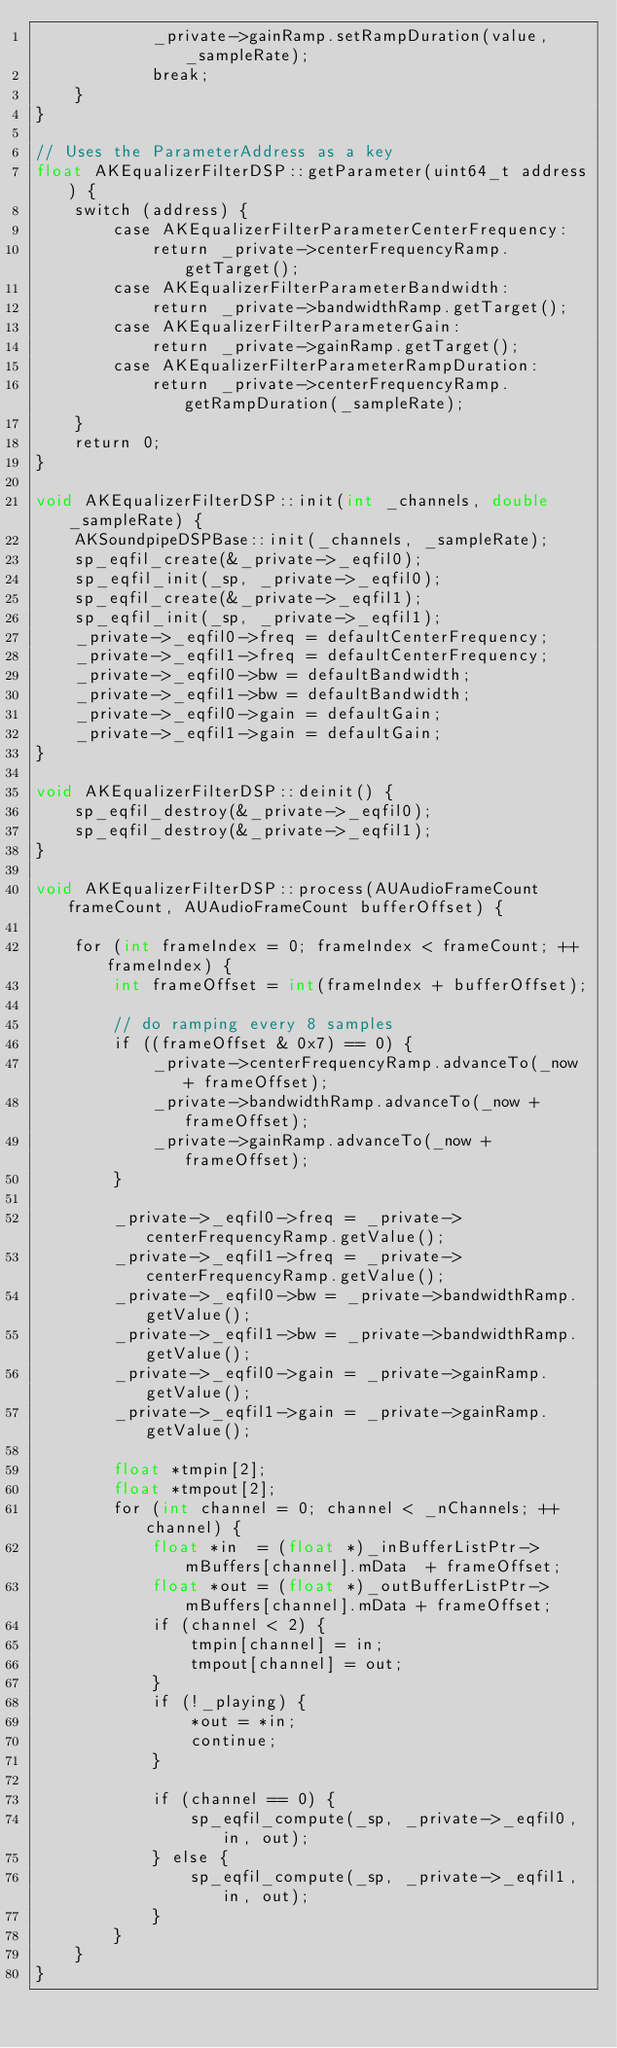<code> <loc_0><loc_0><loc_500><loc_500><_ObjectiveC_>            _private->gainRamp.setRampDuration(value, _sampleRate);
            break;
    }
}

// Uses the ParameterAddress as a key
float AKEqualizerFilterDSP::getParameter(uint64_t address) {
    switch (address) {
        case AKEqualizerFilterParameterCenterFrequency:
            return _private->centerFrequencyRamp.getTarget();
        case AKEqualizerFilterParameterBandwidth:
            return _private->bandwidthRamp.getTarget();
        case AKEqualizerFilterParameterGain:
            return _private->gainRamp.getTarget();
        case AKEqualizerFilterParameterRampDuration:
            return _private->centerFrequencyRamp.getRampDuration(_sampleRate);
    }
    return 0;
}

void AKEqualizerFilterDSP::init(int _channels, double _sampleRate) {
    AKSoundpipeDSPBase::init(_channels, _sampleRate);
    sp_eqfil_create(&_private->_eqfil0);
    sp_eqfil_init(_sp, _private->_eqfil0);
    sp_eqfil_create(&_private->_eqfil1);
    sp_eqfil_init(_sp, _private->_eqfil1);
    _private->_eqfil0->freq = defaultCenterFrequency;
    _private->_eqfil1->freq = defaultCenterFrequency;
    _private->_eqfil0->bw = defaultBandwidth;
    _private->_eqfil1->bw = defaultBandwidth;
    _private->_eqfil0->gain = defaultGain;
    _private->_eqfil1->gain = defaultGain;
}

void AKEqualizerFilterDSP::deinit() {
    sp_eqfil_destroy(&_private->_eqfil0);
    sp_eqfil_destroy(&_private->_eqfil1);
}

void AKEqualizerFilterDSP::process(AUAudioFrameCount frameCount, AUAudioFrameCount bufferOffset) {

    for (int frameIndex = 0; frameIndex < frameCount; ++frameIndex) {
        int frameOffset = int(frameIndex + bufferOffset);

        // do ramping every 8 samples
        if ((frameOffset & 0x7) == 0) {
            _private->centerFrequencyRamp.advanceTo(_now + frameOffset);
            _private->bandwidthRamp.advanceTo(_now + frameOffset);
            _private->gainRamp.advanceTo(_now + frameOffset);
        }

        _private->_eqfil0->freq = _private->centerFrequencyRamp.getValue();
        _private->_eqfil1->freq = _private->centerFrequencyRamp.getValue();
        _private->_eqfil0->bw = _private->bandwidthRamp.getValue();
        _private->_eqfil1->bw = _private->bandwidthRamp.getValue();
        _private->_eqfil0->gain = _private->gainRamp.getValue();
        _private->_eqfil1->gain = _private->gainRamp.getValue();

        float *tmpin[2];
        float *tmpout[2];
        for (int channel = 0; channel < _nChannels; ++channel) {
            float *in  = (float *)_inBufferListPtr->mBuffers[channel].mData  + frameOffset;
            float *out = (float *)_outBufferListPtr->mBuffers[channel].mData + frameOffset;
            if (channel < 2) {
                tmpin[channel] = in;
                tmpout[channel] = out;
            }
            if (!_playing) {
                *out = *in;
                continue;
            }

            if (channel == 0) {
                sp_eqfil_compute(_sp, _private->_eqfil0, in, out);
            } else {
                sp_eqfil_compute(_sp, _private->_eqfil1, in, out);
            }
        }
    }
}
</code> 